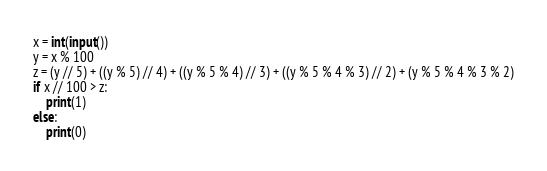<code> <loc_0><loc_0><loc_500><loc_500><_Python_>x = int(input())
y = x % 100
z = (y // 5) + ((y % 5) // 4) + ((y % 5 % 4) // 3) + ((y % 5 % 4 % 3) // 2) + (y % 5 % 4 % 3 % 2)
if x // 100 > z:
    print(1)
else:
    print(0)
</code> 